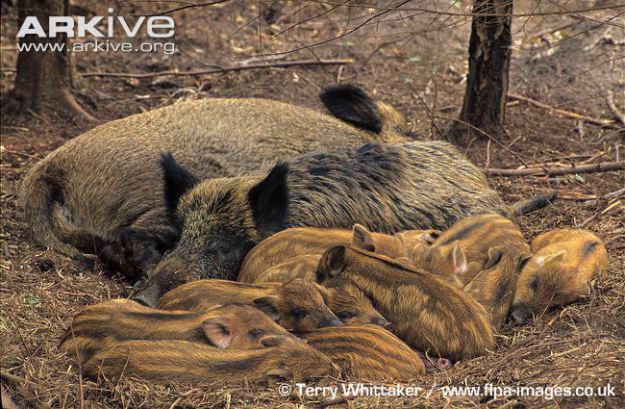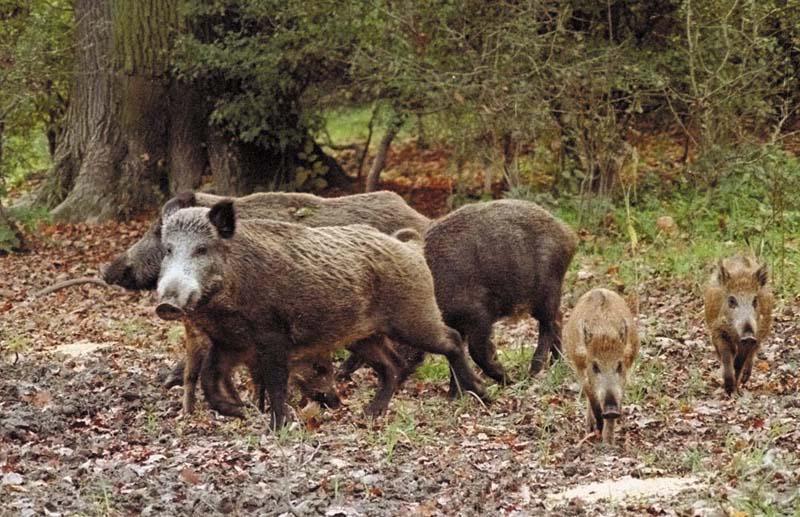The first image is the image on the left, the second image is the image on the right. For the images displayed, is the sentence "There are exactly three pigs." factually correct? Answer yes or no. No. The first image is the image on the left, the second image is the image on the right. For the images displayed, is the sentence "There are three hogs in the pair of images." factually correct? Answer yes or no. No. 